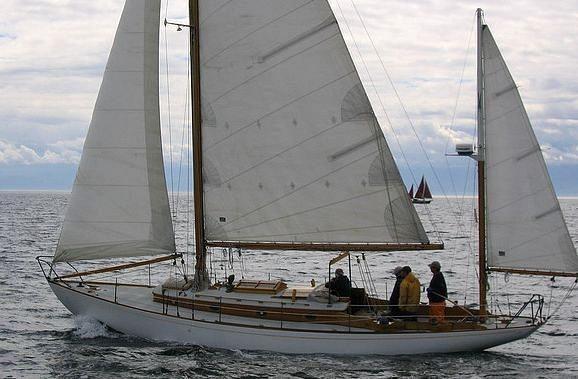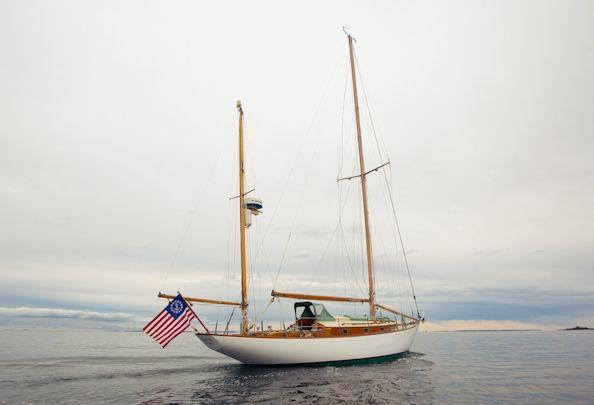The first image is the image on the left, the second image is the image on the right. Considering the images on both sides, is "One image shows a boat that is not in a body of water." valid? Answer yes or no. No. 